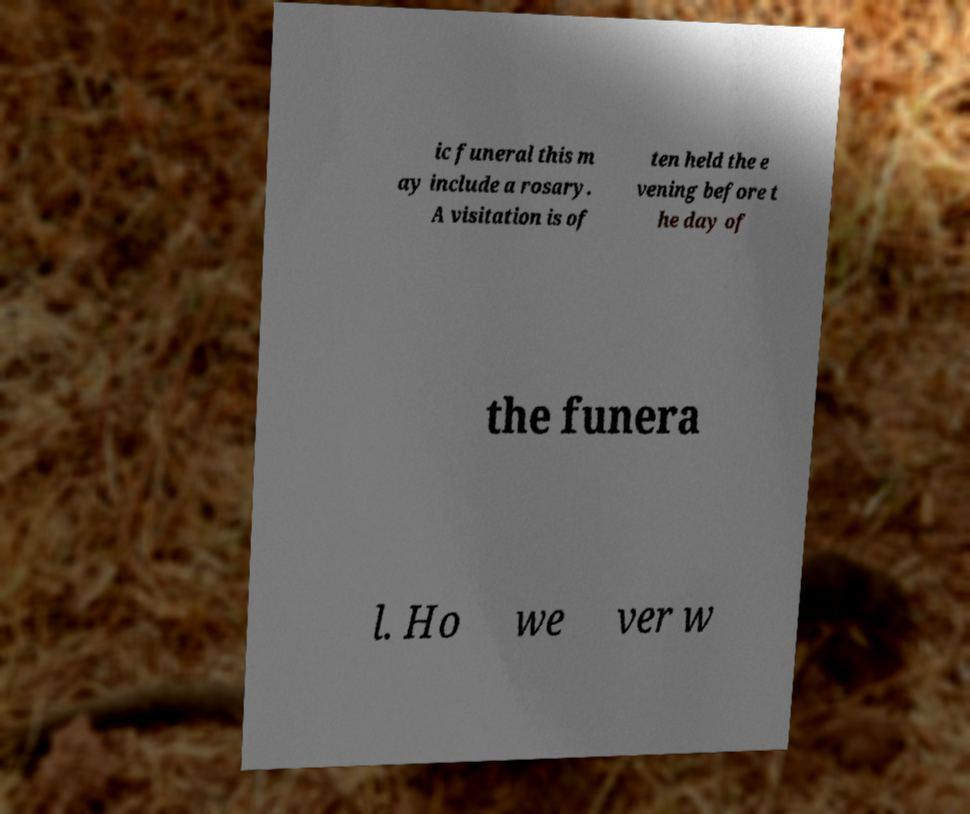There's text embedded in this image that I need extracted. Can you transcribe it verbatim? ic funeral this m ay include a rosary. A visitation is of ten held the e vening before t he day of the funera l. Ho we ver w 